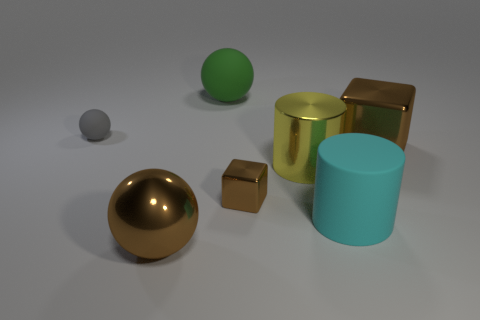Can you describe the atmosphere or mood conveyed by the arrangement and lighting of these objects? The image conveys a serene and almost contemplative atmosphere, where the soft lighting and the neutral background highlight the simplicity and symmetry of the shapes. There's a sense of order and balance, as the objects are placed in a way that seems intentional, yet still feels natural and not overly staged. The lighting casts gentle shadows that contribute to the tranquil and understated mood of the scene. 